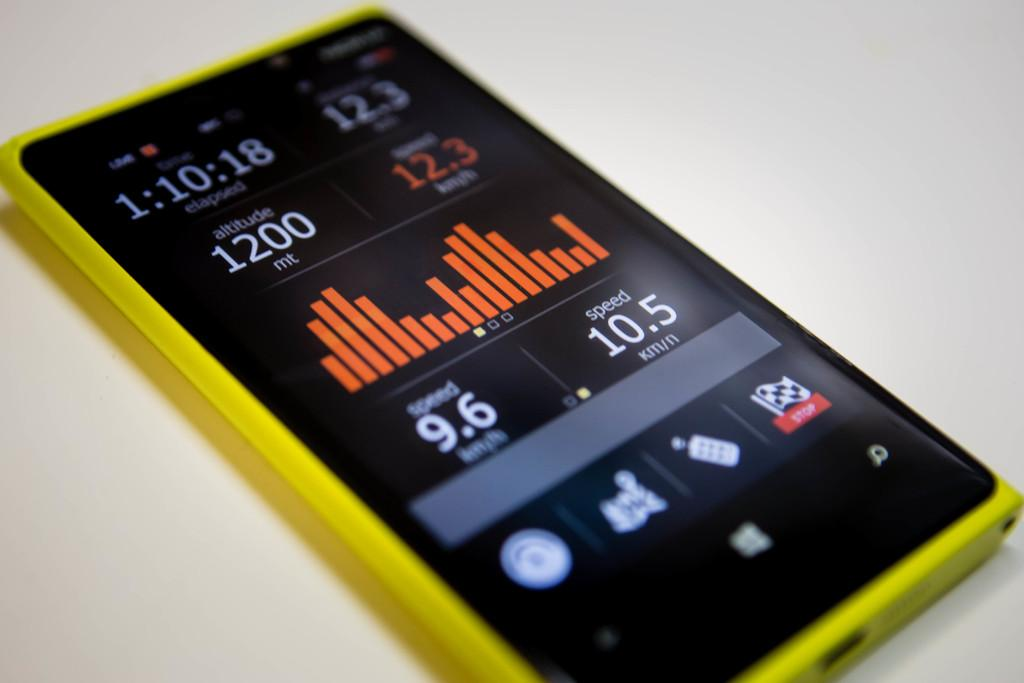<image>
Share a concise interpretation of the image provided. A small yellow monitor display with speed and altitude shown. 